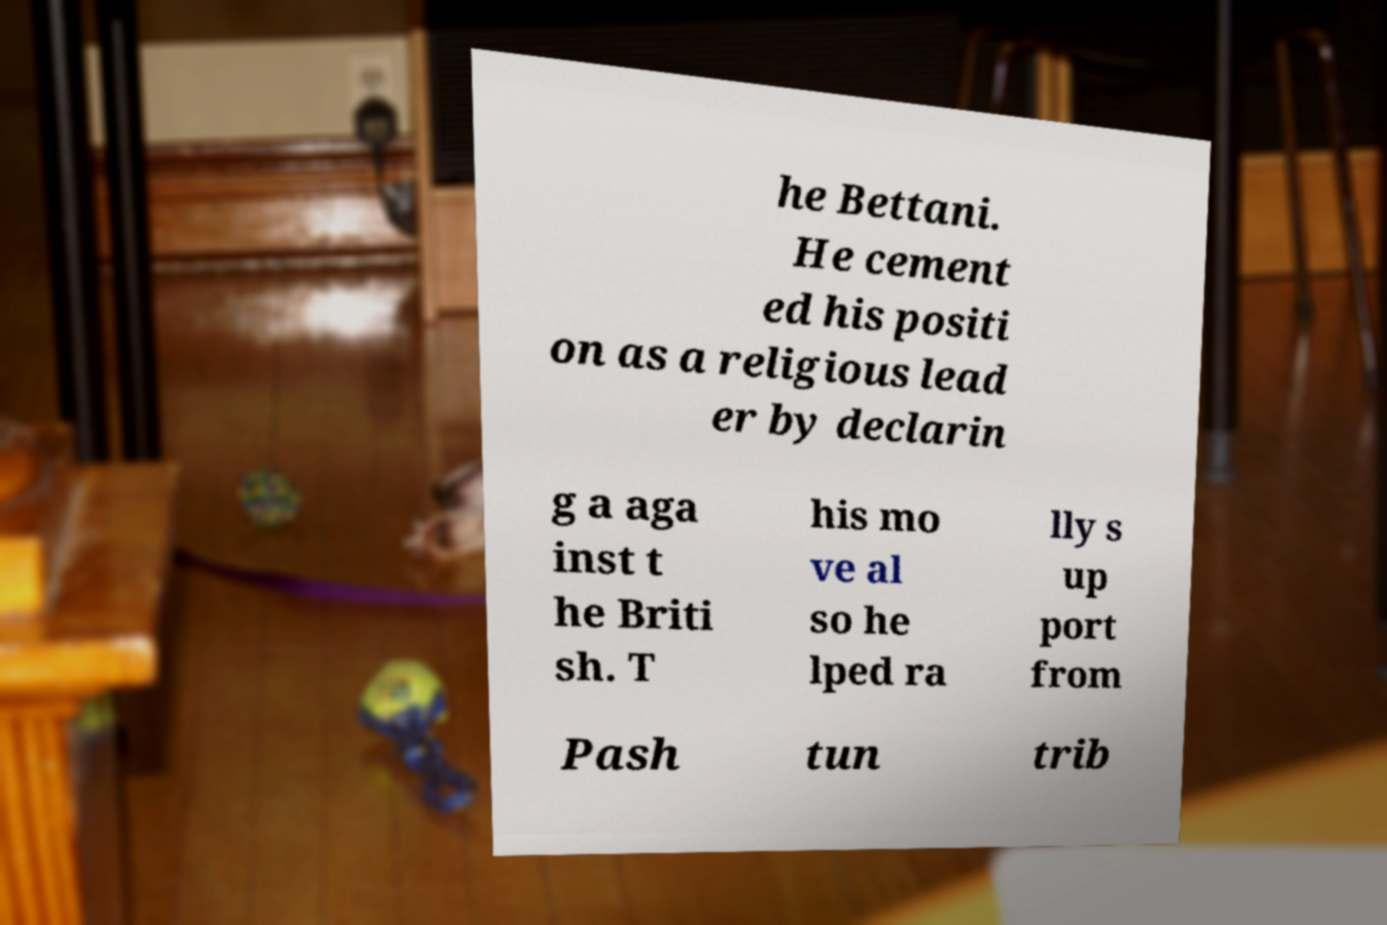I need the written content from this picture converted into text. Can you do that? he Bettani. He cement ed his positi on as a religious lead er by declarin g a aga inst t he Briti sh. T his mo ve al so he lped ra lly s up port from Pash tun trib 